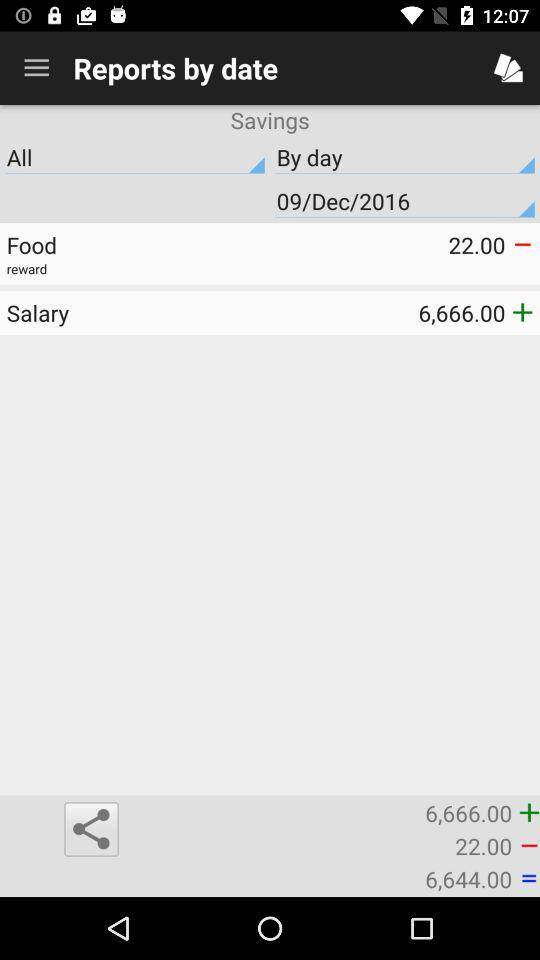How much money is in savings?
Answer the question using a single word or phrase. 6,644.00 